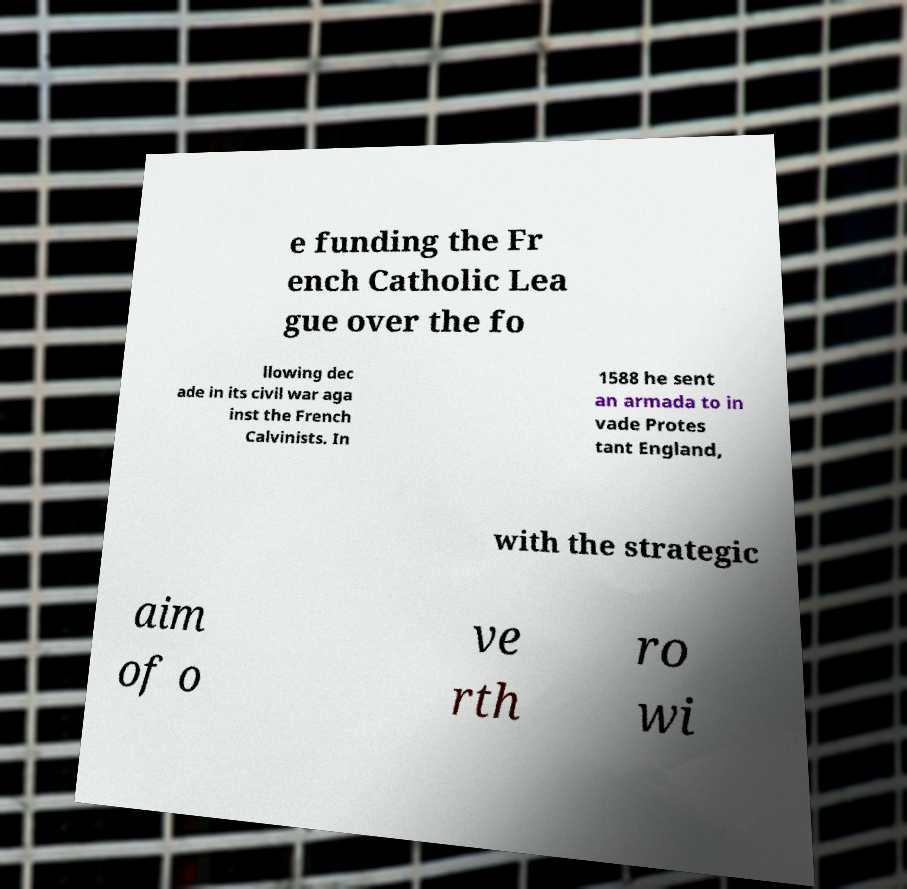Please identify and transcribe the text found in this image. e funding the Fr ench Catholic Lea gue over the fo llowing dec ade in its civil war aga inst the French Calvinists. In 1588 he sent an armada to in vade Protes tant England, with the strategic aim of o ve rth ro wi 